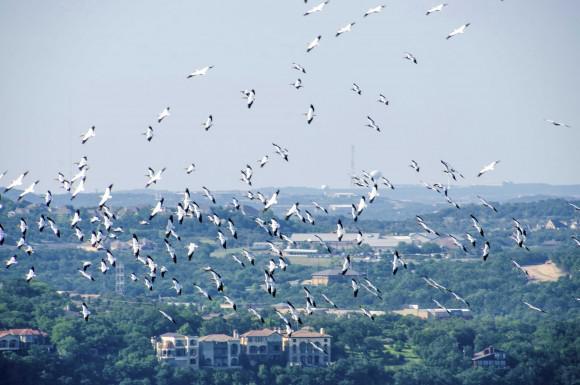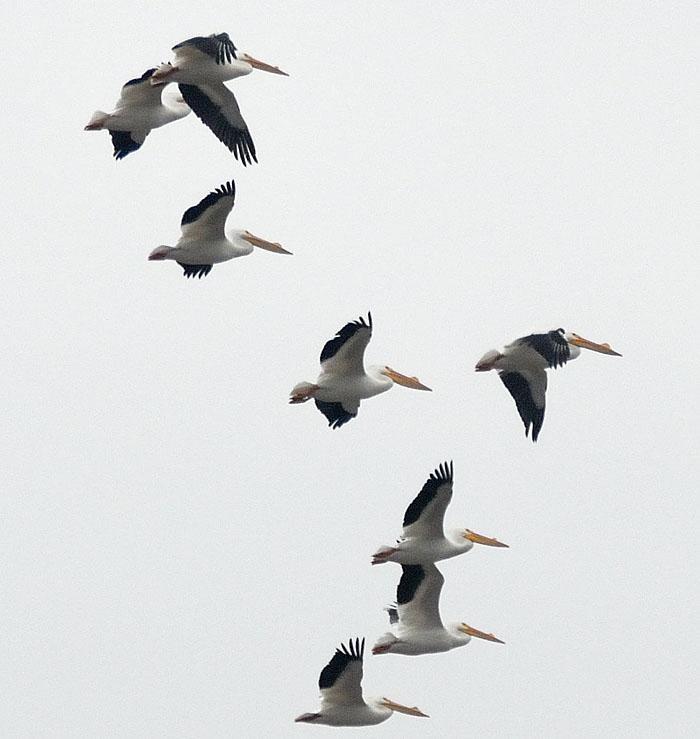The first image is the image on the left, the second image is the image on the right. Analyze the images presented: Is the assertion "In one image there are some birds above the water." valid? Answer yes or no. No. The first image is the image on the left, the second image is the image on the right. Considering the images on both sides, is "The right image contains a wispy cloud and birds flying in formation." valid? Answer yes or no. No. 